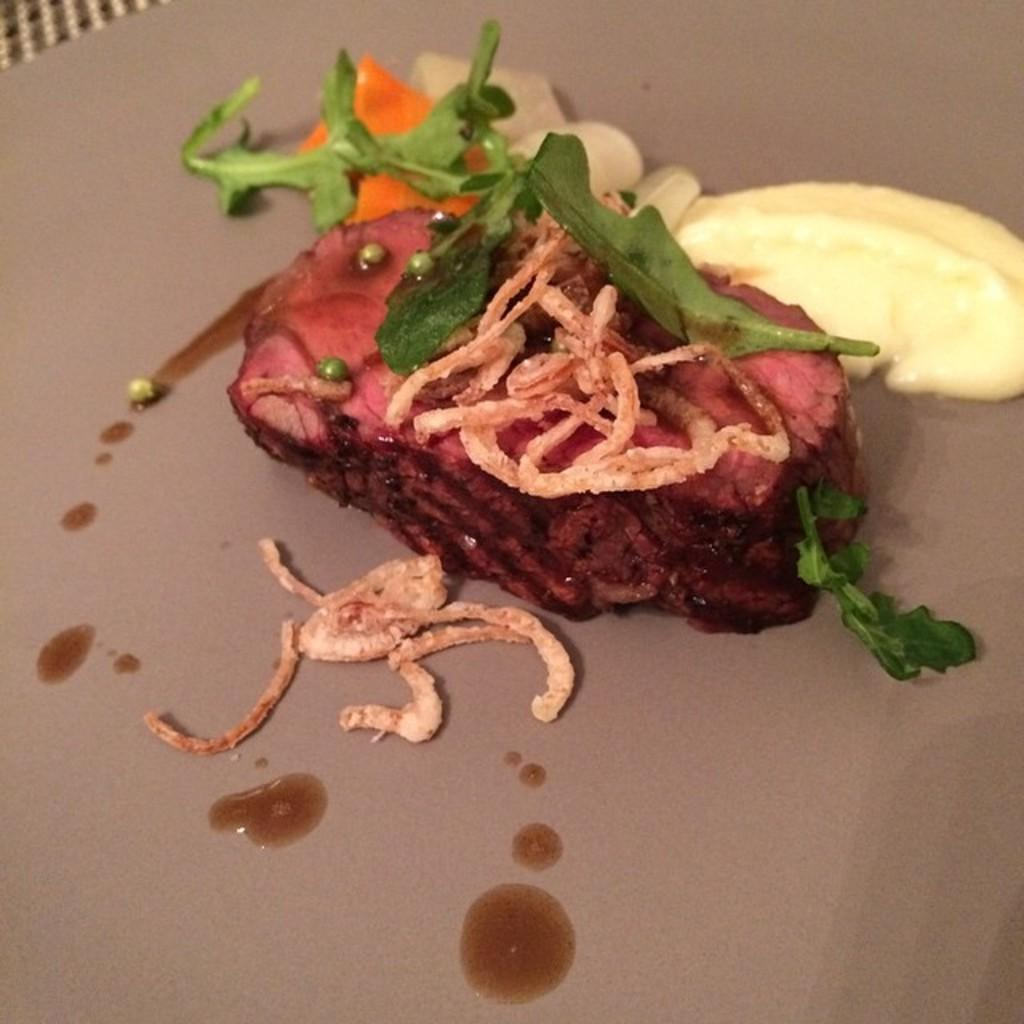What is on the plate in the image? There is food on a plate in the image. How many chairs are visible in the image? There is no chair present in the image; it only shows food on a plate. What type of fruit is placed next to the food on the plate? There is no fruit, specifically a banana, present in the image; it only shows food on a plate. 